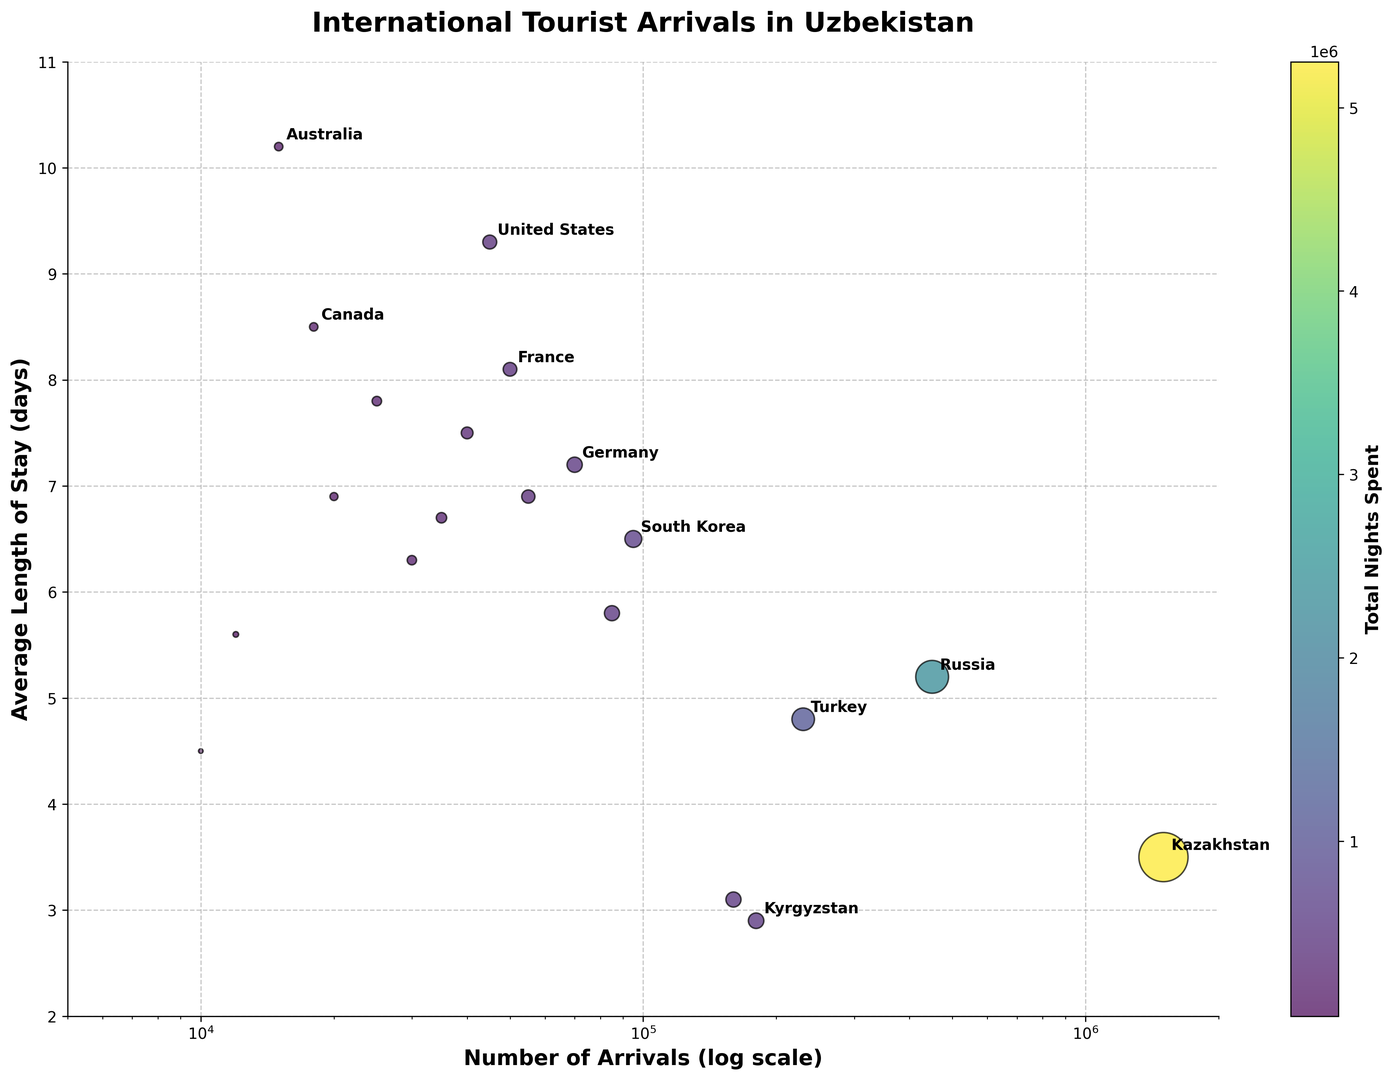What's the country of origin with the highest number of international tourist arrivals in Uzbekistan? By observing the x-axis which represents the number of arrivals, the bubble for Kazakhstan is positioned the farthest to the right indicating it has the most arrivals.
Answer: Kazakhstan Which country has the highest average length of stay? By observing the y-axis which represents the average length of stay, the bubble for Australia is positioned the highest on the chart at 10.2 days.
Answer: Australia Which countries have total nights spent greater than 500,000? We look at the size of the bubbles since larger bubbles represent more total nights spent. Kazakhstan and Russia have particularly large bubbles indicating their total nights spent is above 500,000.
Answer: Kazakhstan, Russia What is the average length of stay difference between South Korea and Japan? The average length of stay for South Korea is 6.5 days, and for Japan, it is 6.7 days. The difference is 6.7 - 6.5 = 0.2 days.
Answer: 0.2 days Which bubble is the largest in terms of circle area, and what does it represent? The largest bubble size indicates the total nights spent, and it's Kazakhstan. Kazakhstan's bubble is the largest, mainly due to its high number of arrivals and roughly average length of stay.
Answer: Kazakhstan Compare the total number of nights spent by tourists from Germany and Canada. Which is higher? Germany has a total of 504,000 nights and Canada has 153,000 total nights spent. Thus, Germany's total nights spent is higher.
Answer: Germany Which countries have an average length of stay above 8 days and are labeled on the chart? Observing the y-axis and corresponding bubble labels, we see that the countries with an average length of stay above 8 days are France (8.1), United States (9.3), and Australia (10.2).
Answer: France, United States, Australia What's the total number of nights spent by tourists from France and Italy combined? Summing up the total nights spent from France (405,000) and Italy (189,000), we get 405,000 + 189,000 = 594,000 nights.
Answer: 594,000 Which country has the smallest number of arrivals but a high average length of stay? The country with the smallest number of arrivals that we can extract from the x-axis at a minimum of 10,000 is Ukraine. However, checking for a high average length of stay we notice that Australia with 15,000 arrivals and 10.2 days fits the criteria better.
Answer: Australia What's the rank of the United States in terms of average length of stay? By visually inspecting the y-values and counting up, Australia (10.2), United States (9.3), and then France (8.1), indicates the rank of the United States as second rank.
Answer: 2nd 